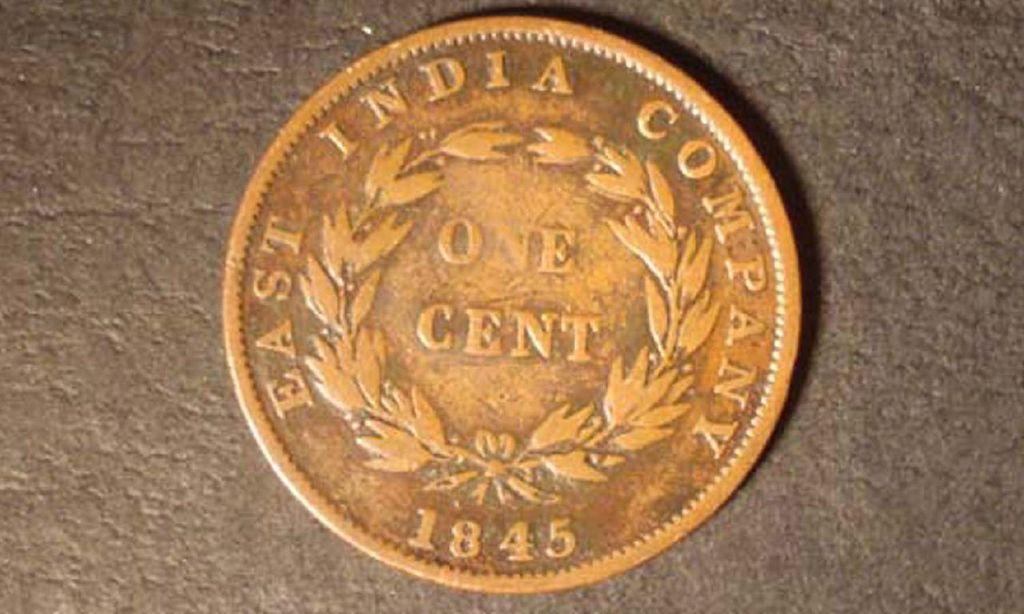<image>
Relay a brief, clear account of the picture shown. A one cent coin engraved with EAST INDIA COMPANY 1845 